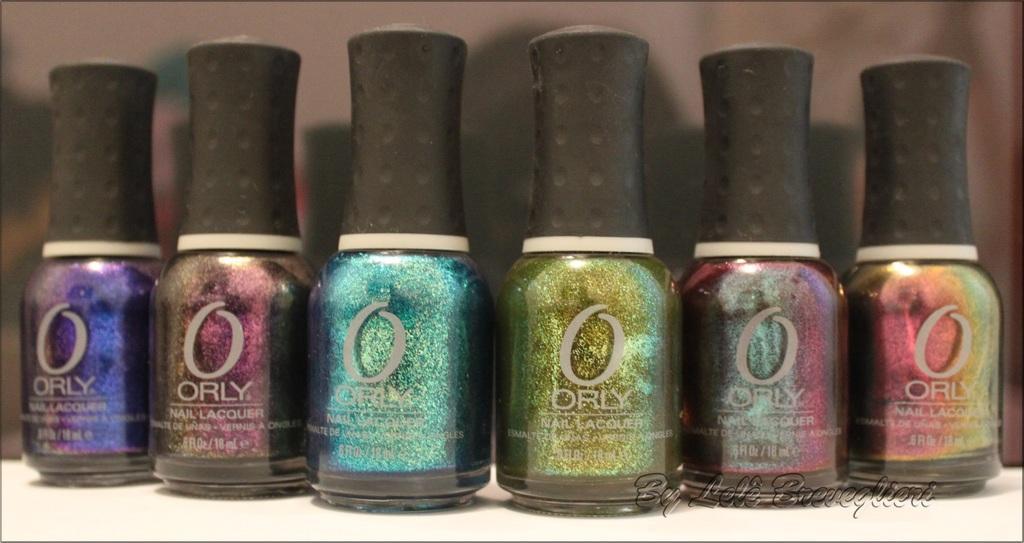In one or two sentences, can you explain what this image depicts? In this image, we can see bottles on white surface. There is a text in the bottom right of the image. 